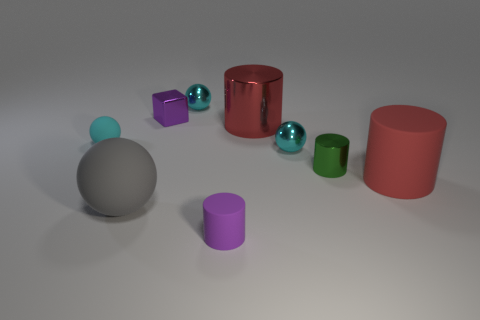Subtract all blue blocks. How many cyan balls are left? 3 Add 1 red rubber cylinders. How many objects exist? 10 Subtract all spheres. How many objects are left? 5 Add 5 small green metal things. How many small green metal things are left? 6 Add 2 cyan shiny balls. How many cyan shiny balls exist? 4 Subtract 0 blue spheres. How many objects are left? 9 Subtract all gray rubber spheres. Subtract all small yellow matte spheres. How many objects are left? 8 